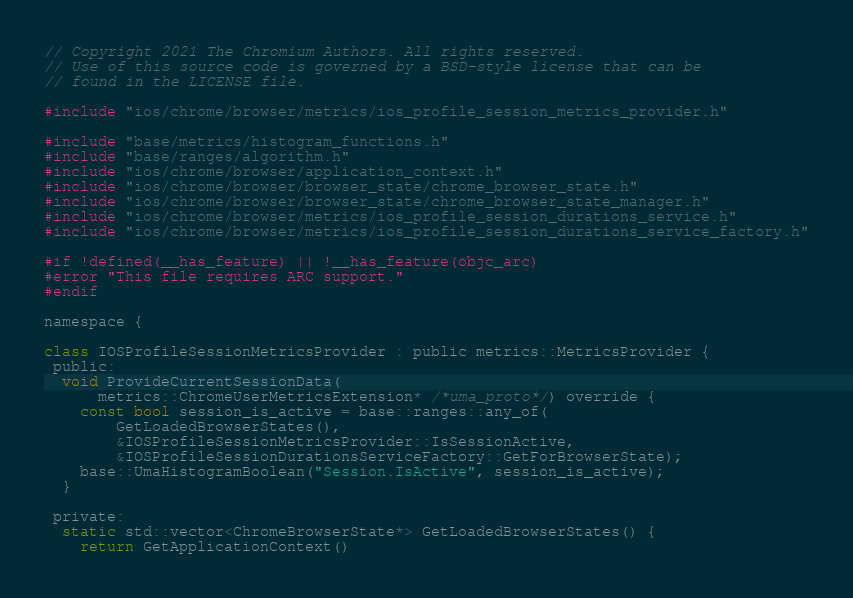Convert code to text. <code><loc_0><loc_0><loc_500><loc_500><_ObjectiveC_>// Copyright 2021 The Chromium Authors. All rights reserved.
// Use of this source code is governed by a BSD-style license that can be
// found in the LICENSE file.

#include "ios/chrome/browser/metrics/ios_profile_session_metrics_provider.h"

#include "base/metrics/histogram_functions.h"
#include "base/ranges/algorithm.h"
#include "ios/chrome/browser/application_context.h"
#include "ios/chrome/browser/browser_state/chrome_browser_state.h"
#include "ios/chrome/browser/browser_state/chrome_browser_state_manager.h"
#include "ios/chrome/browser/metrics/ios_profile_session_durations_service.h"
#include "ios/chrome/browser/metrics/ios_profile_session_durations_service_factory.h"

#if !defined(__has_feature) || !__has_feature(objc_arc)
#error "This file requires ARC support."
#endif

namespace {

class IOSProfileSessionMetricsProvider : public metrics::MetricsProvider {
 public:
  void ProvideCurrentSessionData(
      metrics::ChromeUserMetricsExtension* /*uma_proto*/) override {
    const bool session_is_active = base::ranges::any_of(
        GetLoadedBrowserStates(),
        &IOSProfileSessionMetricsProvider::IsSessionActive,
        &IOSProfileSessionDurationsServiceFactory::GetForBrowserState);
    base::UmaHistogramBoolean("Session.IsActive", session_is_active);
  }

 private:
  static std::vector<ChromeBrowserState*> GetLoadedBrowserStates() {
    return GetApplicationContext()</code> 